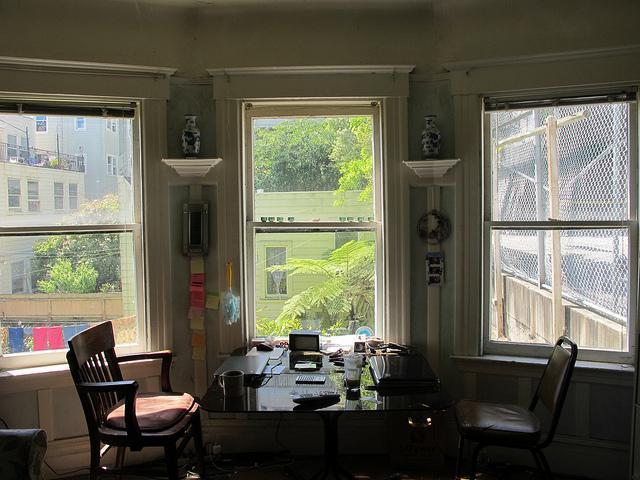How many chairs are around the table?
Give a very brief answer. 2. How many windows are on the building?
Give a very brief answer. 3. How many chairs can you see?
Give a very brief answer. 2. 